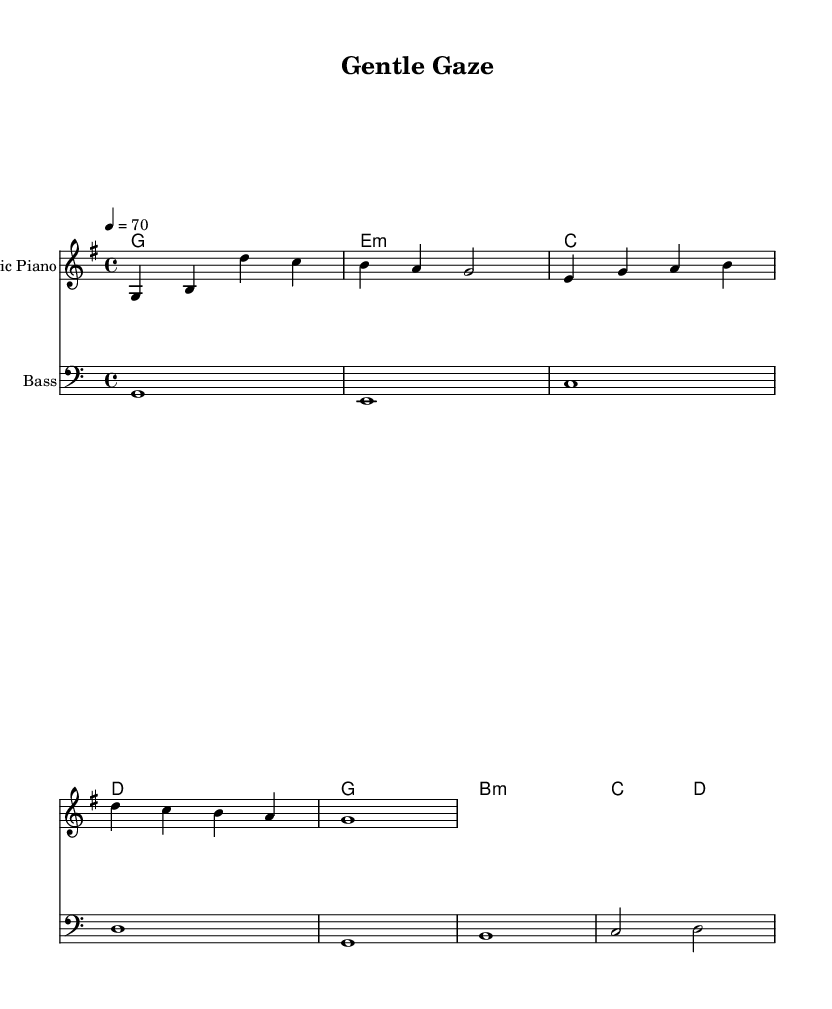What is the key signature of this music? The key signature shows one sharp (F#), indicating that the key is G major.
Answer: G major What is the time signature of this music? The time signature at the beginning of the score is 4 over 4, which is a common time signature.
Answer: 4/4 What is the tempo marking for this piece? The tempo marking indicates a pace of 70 beats per minute, suggesting a slow and relaxed feel.
Answer: 70 How many measures are in the melody section? By counting the measures in the melody part, there are a total of four measures.
Answer: Four What is the instrument designated for the melody? The instrument name "Electric Piano" at the top of the melody staff indicates that this is the intended instrument.
Answer: Electric Piano Which chord appears first in the harmony section? Looking at the chord names, the first chord listed is G major, appearing at the beginning of the chord progression.
Answer: G Is the bass line in a higher or lower octave compared to the melody? The bass line is played in a lower octave compared to the melody, which is evident as it uses the bass clef and lower pitch ranges.
Answer: Lower octave 